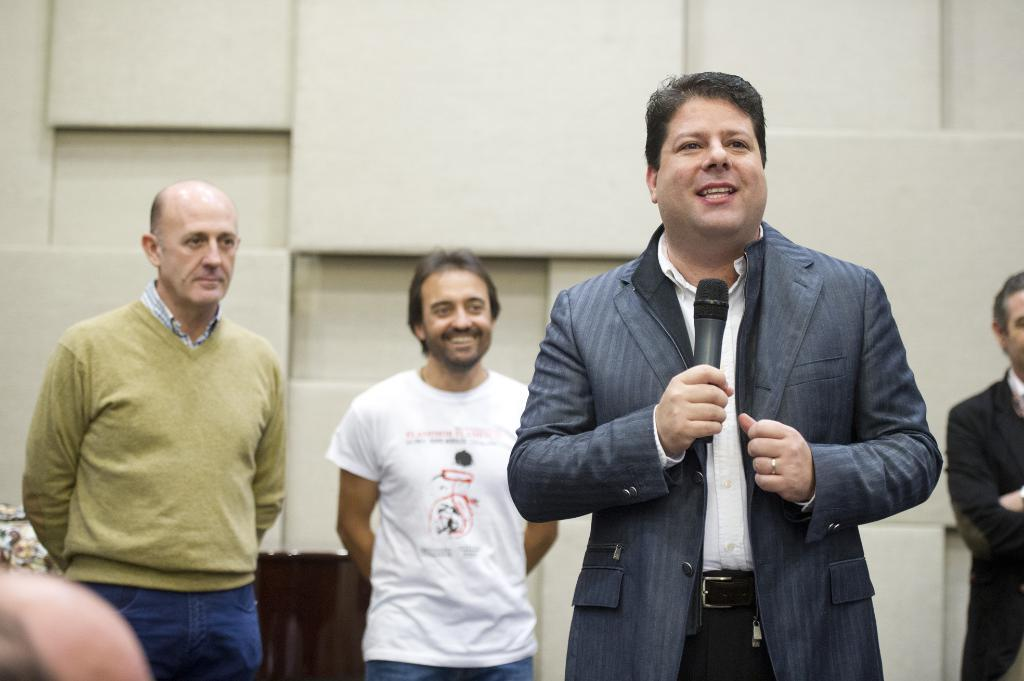Who is the main subject in the image? There is a person in the center of the image. What is the person wearing? The person is wearing a suit. What is the person holding in the image? The person is holding a mic. Can you describe the background of the image? There are other persons in the background of the image, and there is a wall visible. How much snow can be seen falling in the image? There is no snow present in the image. What type of net is being used by the person in the image? The person in the image is not using a net; they are holding a mic. 